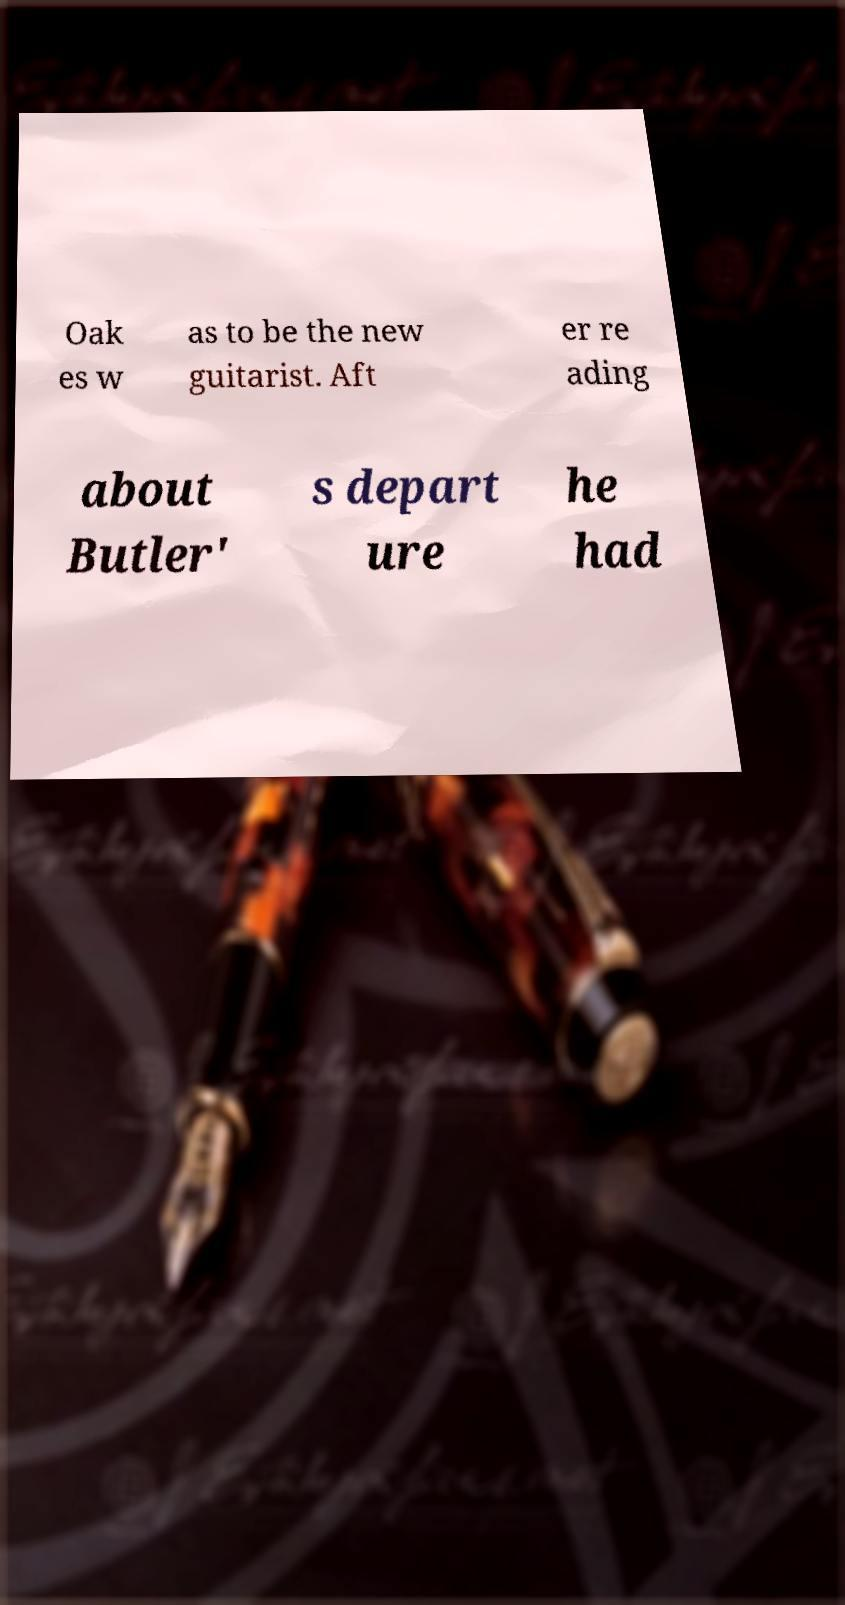Can you accurately transcribe the text from the provided image for me? Oak es w as to be the new guitarist. Aft er re ading about Butler' s depart ure he had 